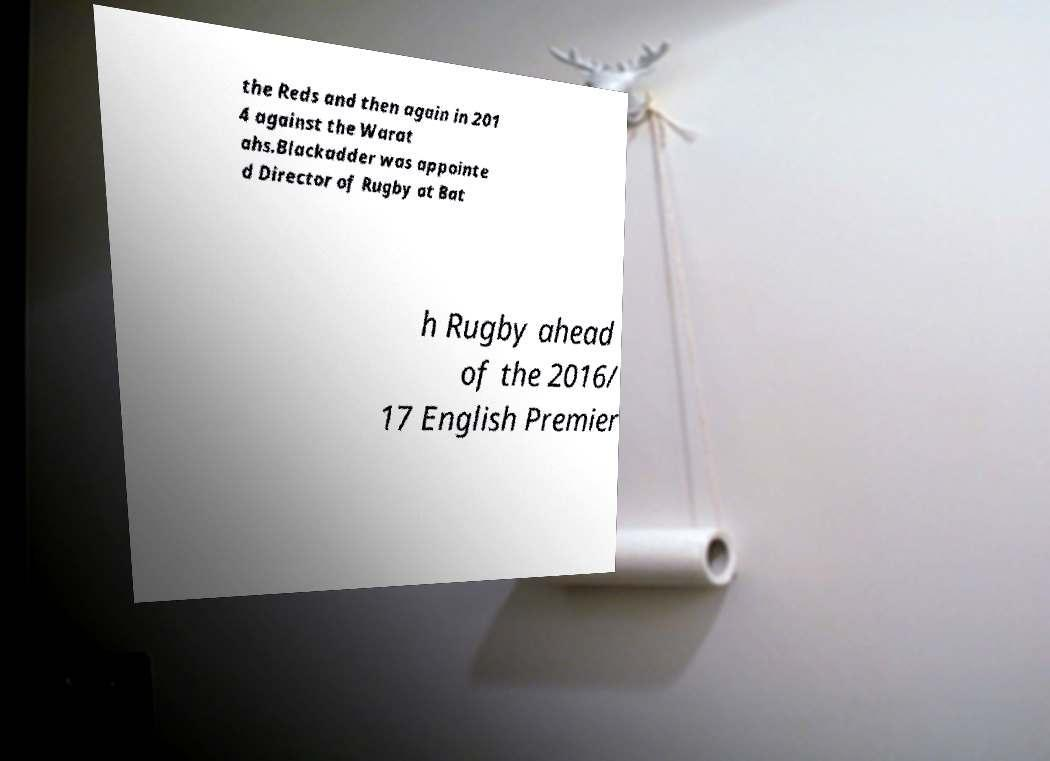What messages or text are displayed in this image? I need them in a readable, typed format. the Reds and then again in 201 4 against the Warat ahs.Blackadder was appointe d Director of Rugby at Bat h Rugby ahead of the 2016/ 17 English Premier 